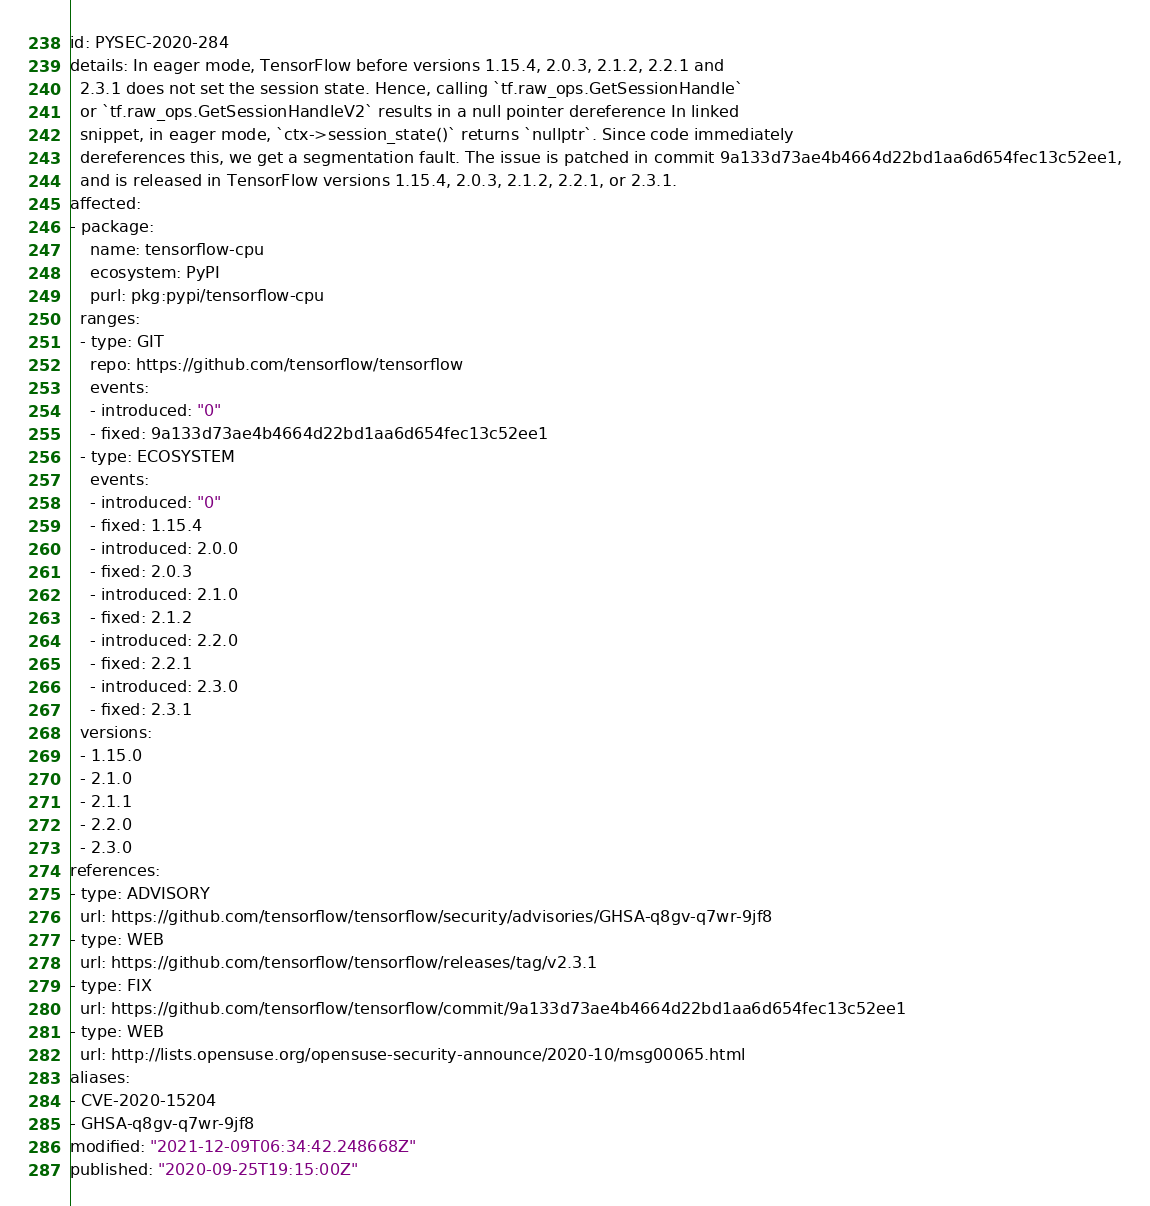Convert code to text. <code><loc_0><loc_0><loc_500><loc_500><_YAML_>id: PYSEC-2020-284
details: In eager mode, TensorFlow before versions 1.15.4, 2.0.3, 2.1.2, 2.2.1 and
  2.3.1 does not set the session state. Hence, calling `tf.raw_ops.GetSessionHandle`
  or `tf.raw_ops.GetSessionHandleV2` results in a null pointer dereference In linked
  snippet, in eager mode, `ctx->session_state()` returns `nullptr`. Since code immediately
  dereferences this, we get a segmentation fault. The issue is patched in commit 9a133d73ae4b4664d22bd1aa6d654fec13c52ee1,
  and is released in TensorFlow versions 1.15.4, 2.0.3, 2.1.2, 2.2.1, or 2.3.1.
affected:
- package:
    name: tensorflow-cpu
    ecosystem: PyPI
    purl: pkg:pypi/tensorflow-cpu
  ranges:
  - type: GIT
    repo: https://github.com/tensorflow/tensorflow
    events:
    - introduced: "0"
    - fixed: 9a133d73ae4b4664d22bd1aa6d654fec13c52ee1
  - type: ECOSYSTEM
    events:
    - introduced: "0"
    - fixed: 1.15.4
    - introduced: 2.0.0
    - fixed: 2.0.3
    - introduced: 2.1.0
    - fixed: 2.1.2
    - introduced: 2.2.0
    - fixed: 2.2.1
    - introduced: 2.3.0
    - fixed: 2.3.1
  versions:
  - 1.15.0
  - 2.1.0
  - 2.1.1
  - 2.2.0
  - 2.3.0
references:
- type: ADVISORY
  url: https://github.com/tensorflow/tensorflow/security/advisories/GHSA-q8gv-q7wr-9jf8
- type: WEB
  url: https://github.com/tensorflow/tensorflow/releases/tag/v2.3.1
- type: FIX
  url: https://github.com/tensorflow/tensorflow/commit/9a133d73ae4b4664d22bd1aa6d654fec13c52ee1
- type: WEB
  url: http://lists.opensuse.org/opensuse-security-announce/2020-10/msg00065.html
aliases:
- CVE-2020-15204
- GHSA-q8gv-q7wr-9jf8
modified: "2021-12-09T06:34:42.248668Z"
published: "2020-09-25T19:15:00Z"
</code> 